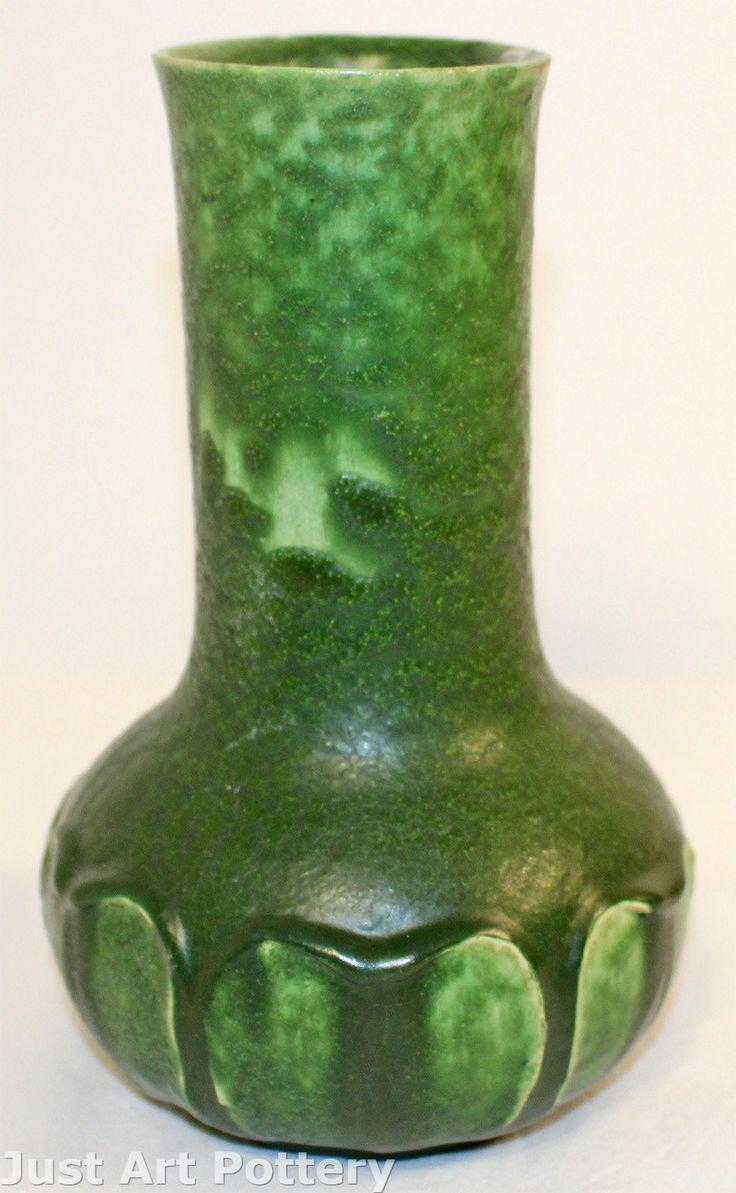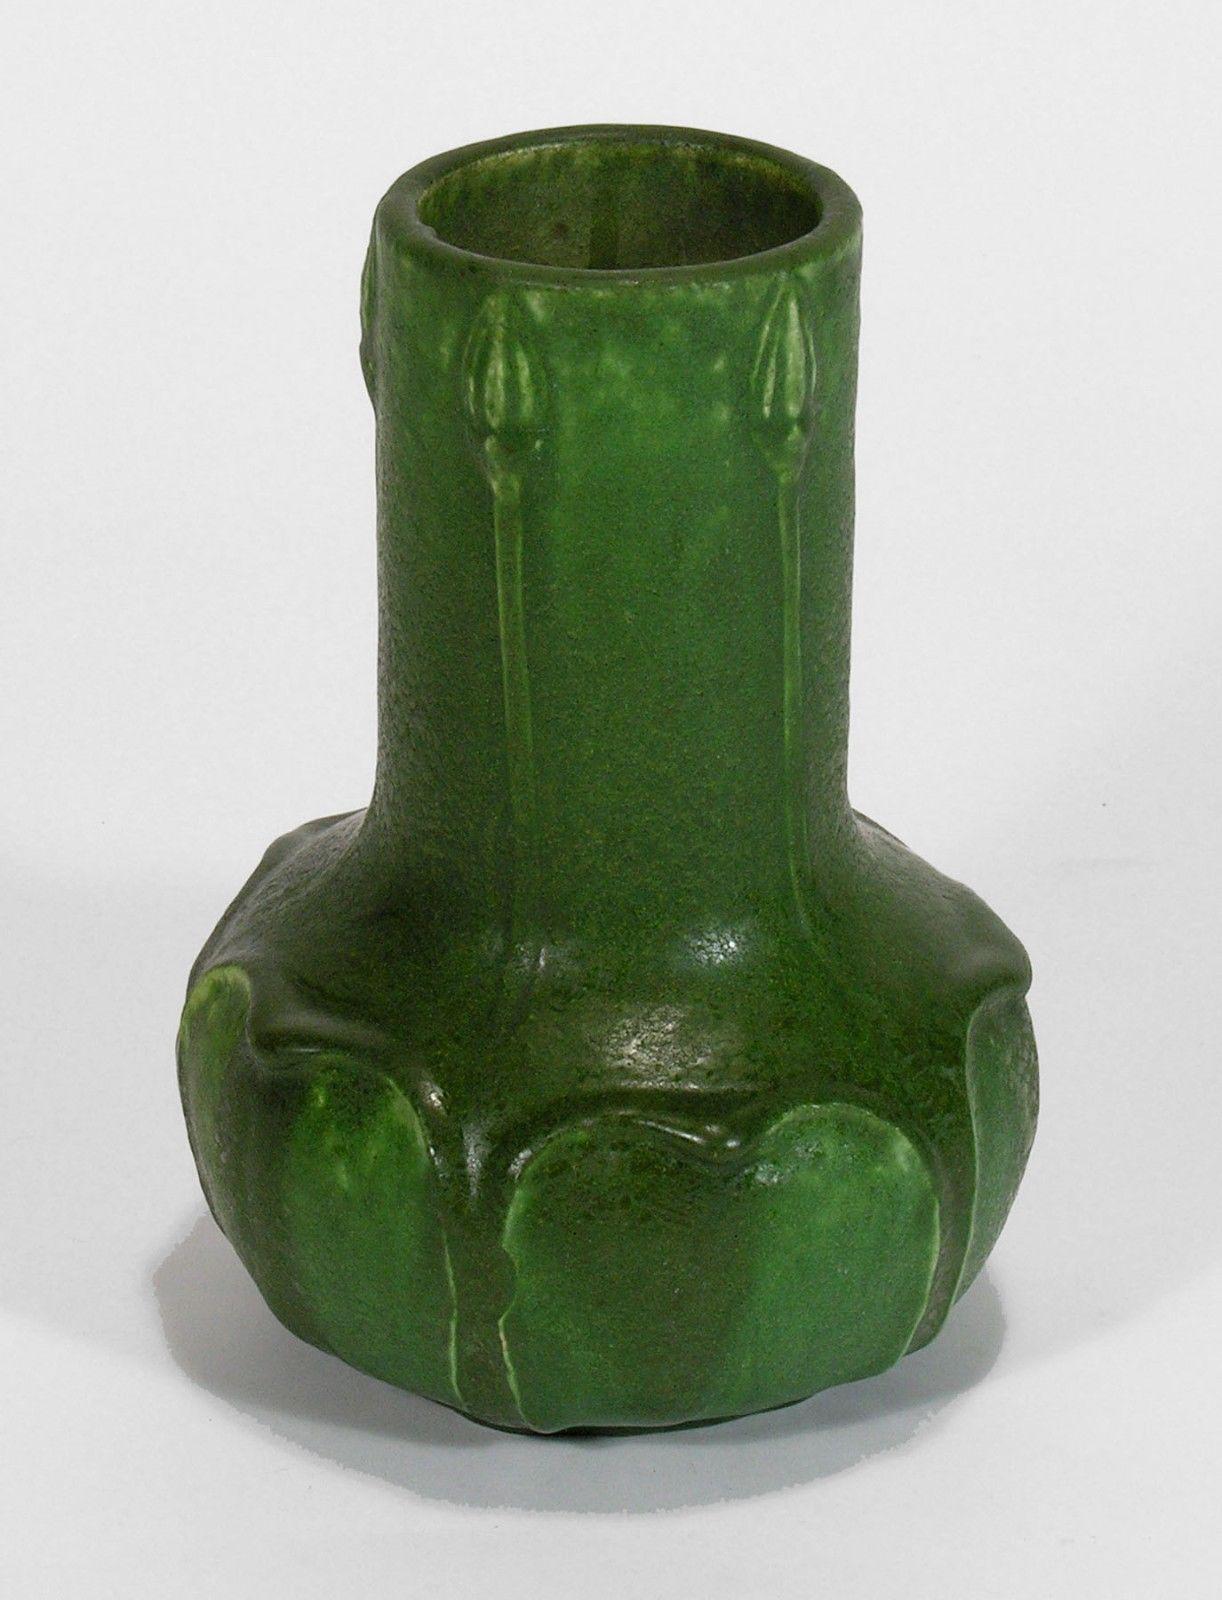The first image is the image on the left, the second image is the image on the right. Given the left and right images, does the statement "All vases are the same green color with a drip effect, and no vases have handles." hold true? Answer yes or no. Yes. 